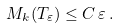<formula> <loc_0><loc_0><loc_500><loc_500>M _ { k } ( T _ { \varepsilon } ) \leq C \, \varepsilon \, .</formula> 